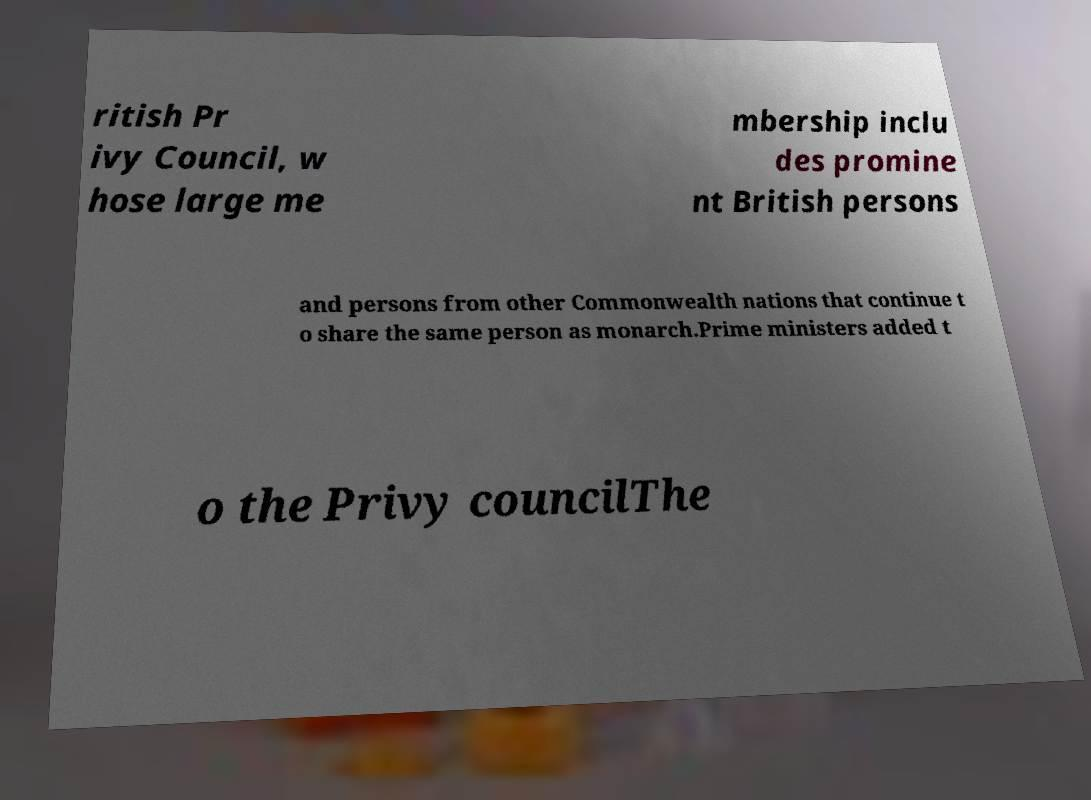Can you accurately transcribe the text from the provided image for me? ritish Pr ivy Council, w hose large me mbership inclu des promine nt British persons and persons from other Commonwealth nations that continue t o share the same person as monarch.Prime ministers added t o the Privy councilThe 